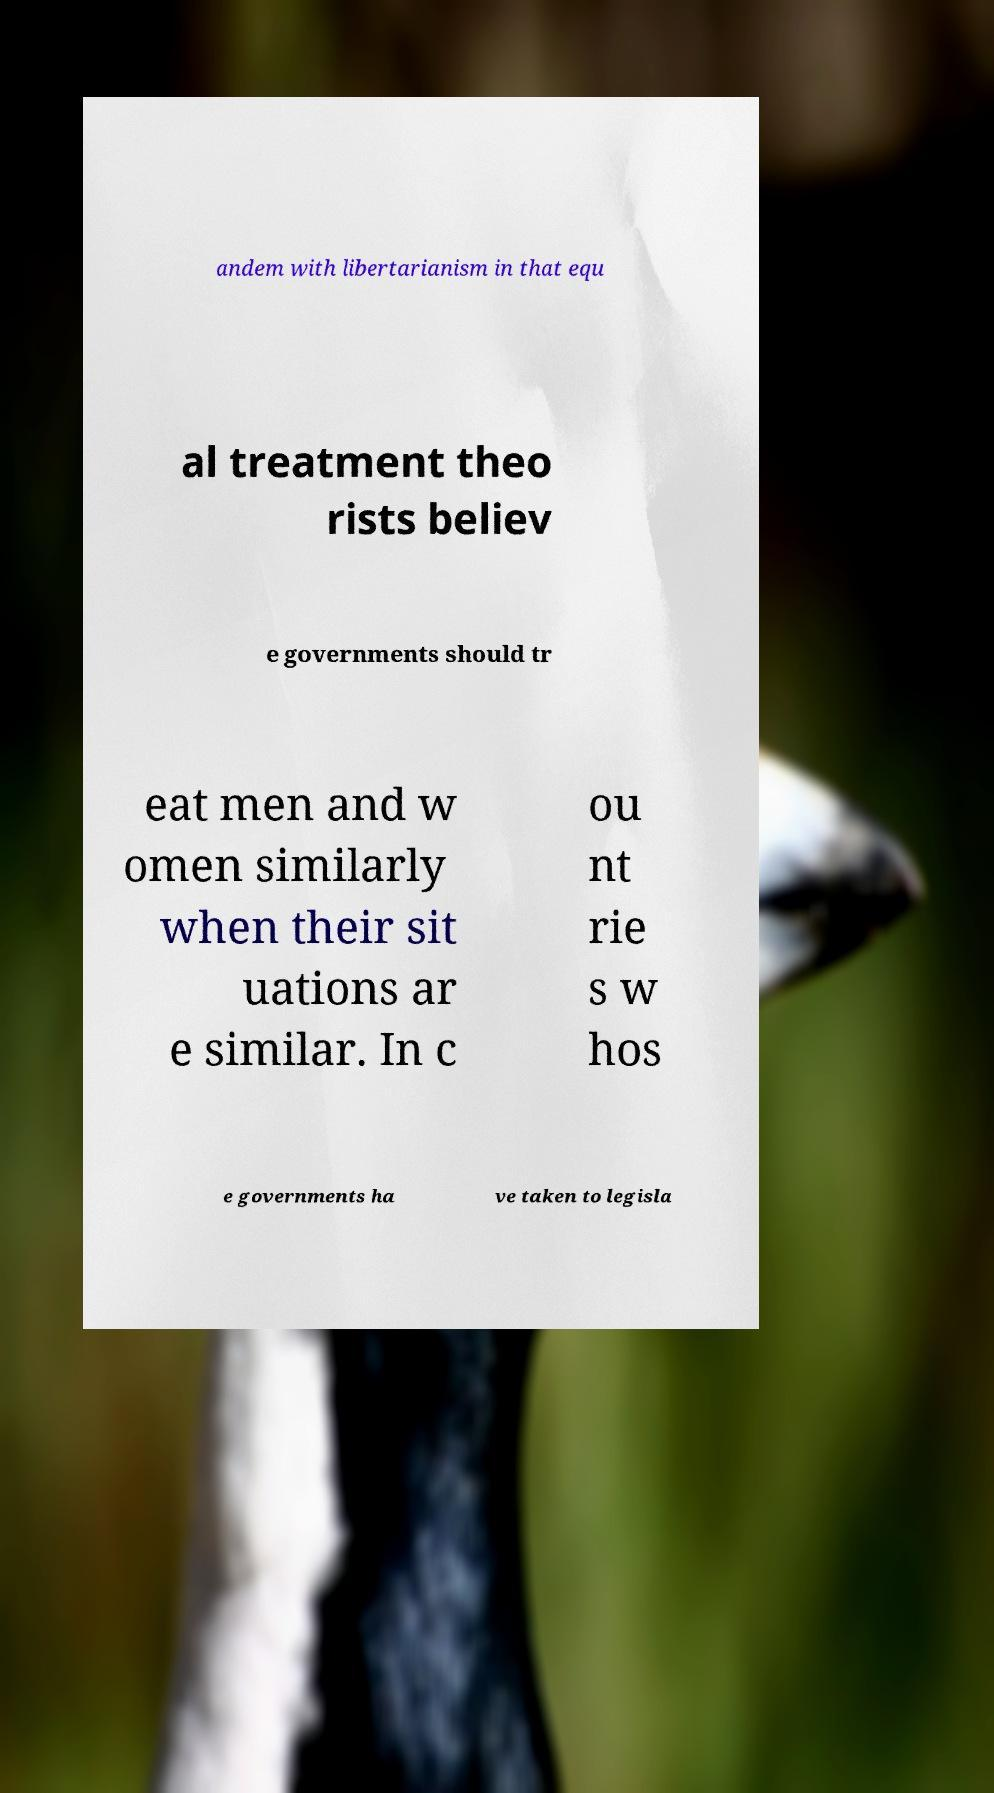Please identify and transcribe the text found in this image. andem with libertarianism in that equ al treatment theo rists believ e governments should tr eat men and w omen similarly when their sit uations ar e similar. In c ou nt rie s w hos e governments ha ve taken to legisla 